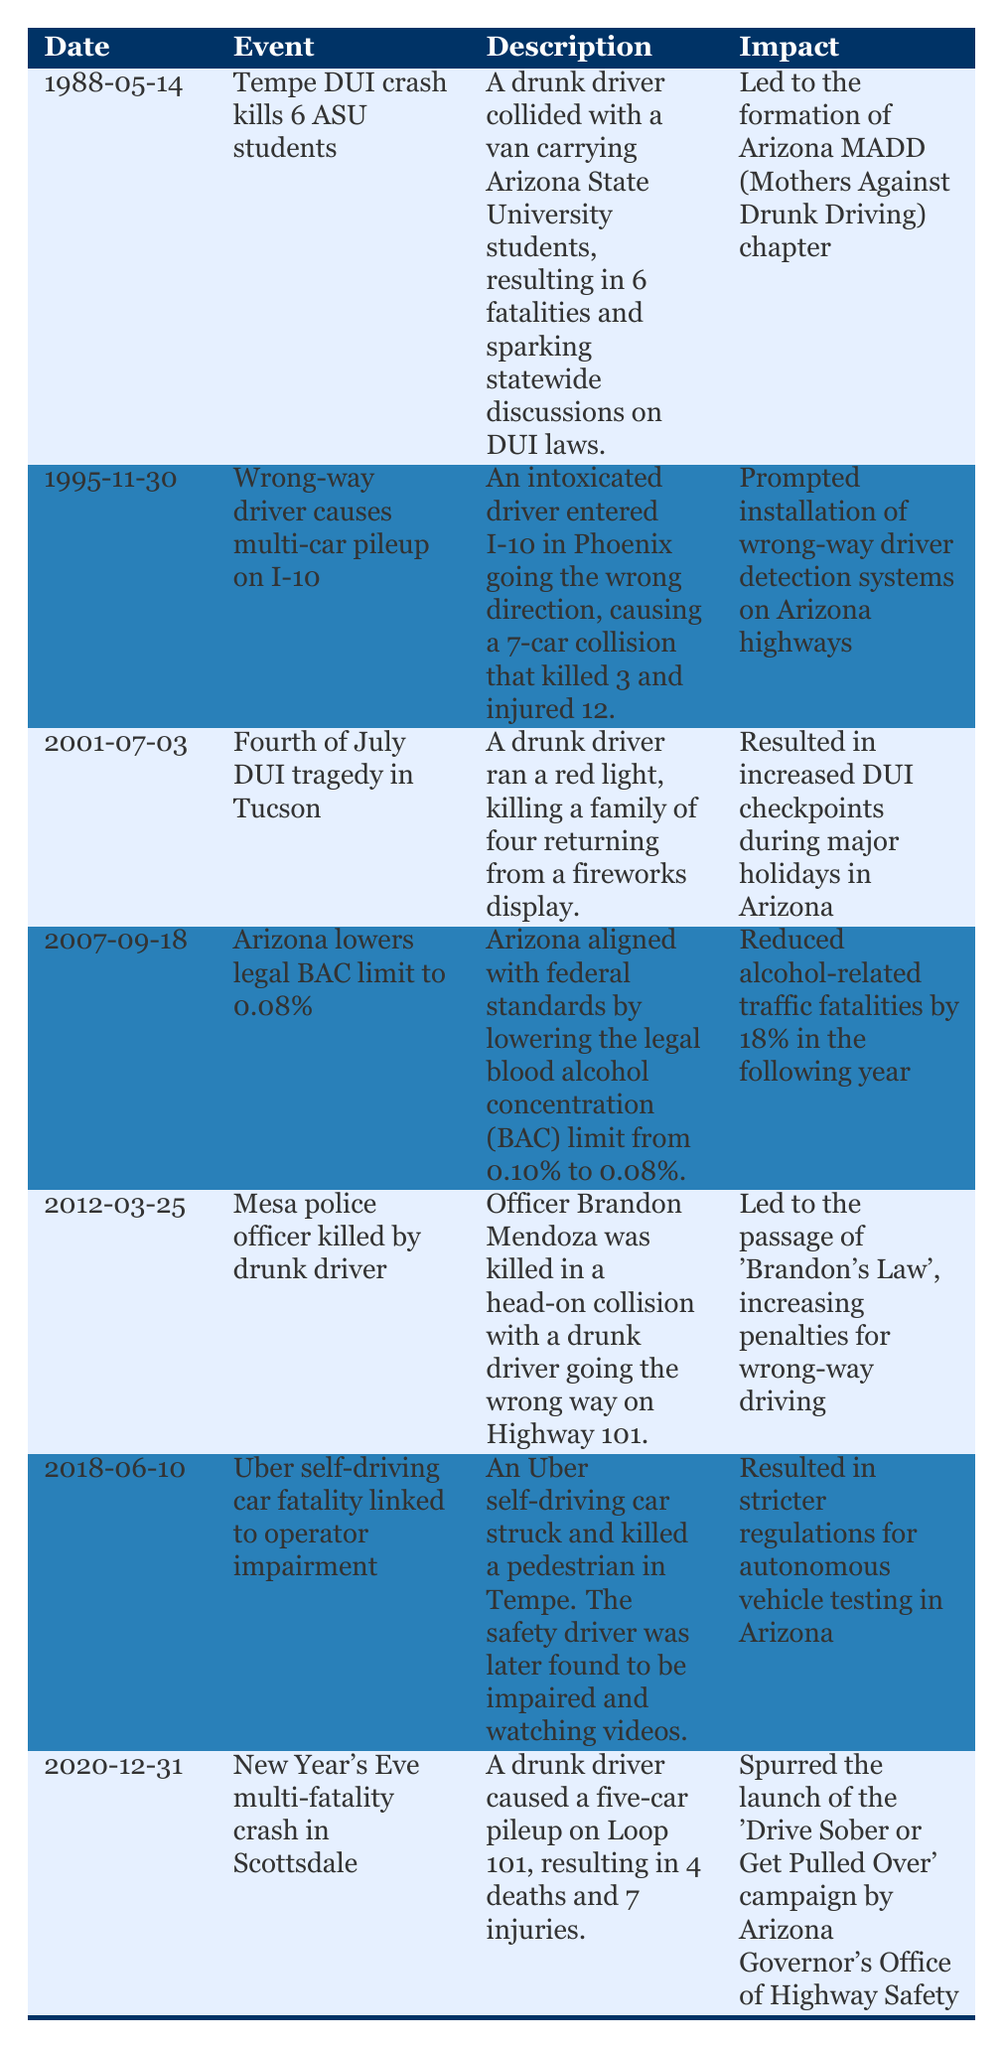What was the date of the Tempe DUI crash that killed 6 ASU students? The table lists the event "Tempe DUI crash kills 6 ASU students" with the date "1988-05-14" in the corresponding row.
Answer: 1988-05-14 How many fatalities resulted from the wrong-way driver incident on I-10? According to the table, the event "Wrong-way driver causes multi-car pileup on I-10" mentions there were 3 fatalities.
Answer: 3 Which event led to the installation of wrong-way driver detection systems on Arizona highways? The event "Wrong-way driver causes multi-car pileup on I-10" prompted this change, as noted in the table under its impact.
Answer: Wrong-way driver causes multi-car pileup on I-10 What is the difference in the legal BAC limits in Arizona before and after the change in 2007? The limit changed from 0.10% to 0.08%. The difference is calculated as 0.10 - 0.08 = 0.02%.
Answer: 0.02% True or False: The Fourth of July DUI tragedy in Tucson resulted in increased DUI checkpoints during major holidays in Arizona. The table confirms this fact in the impact section for that event.
Answer: True How many total fatalities were reported in the incidents listed from 1988 to 2020? The fatalities can be summed from each relevant event: 6 (Tempe crash) + 3 (wrong-way driver) + 4 (Fourth of July) + 1 (Mesa officer) + 4 (New Year's Eve crash) = 18 total fatalities.
Answer: 18 What significant legislation was passed following the death of Officer Brandon Mendoza? The table indicates that "Brandon's Law" increased penalties for wrong-way driving as a result of his death.
Answer: Brandon's Law Did any event in the timeline result in stricter regulations for autonomous vehicle testing in Arizona? The table details that the incident involving the Uber self-driving car resulted in stricter regulations as noted in its impact statement.
Answer: Yes What was the impact of the 2007 decision to lower the legal BAC limit in Arizona? This decision is noted in the table to have reduced alcohol-related traffic fatalities by 18% the following year.
Answer: Reduced alcohol-related traffic fatalities by 18% 